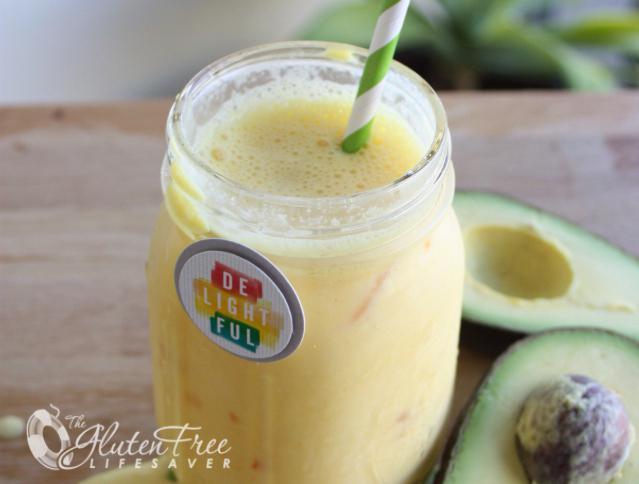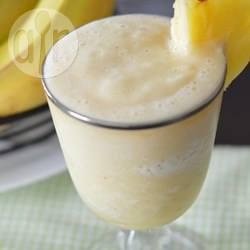The first image is the image on the left, the second image is the image on the right. For the images shown, is this caption "One of the drinks has a straw in it." true? Answer yes or no. Yes. The first image is the image on the left, the second image is the image on the right. Given the left and right images, does the statement "One glass of creamy beverage has a straw standing in it, and at least one glass of creamy beverage has a wedge of fruit on the rim of the glass." hold true? Answer yes or no. Yes. 